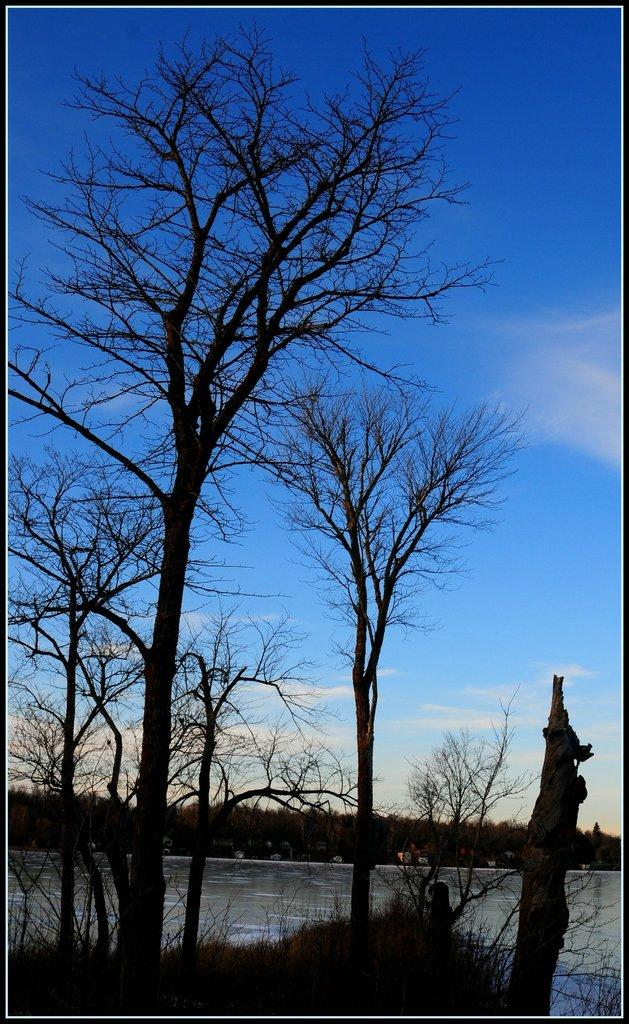What type of vegetation is present in the image? There is grass in the image. What is the condition of the trees in the image? The trees in the image are dry. What can be seen in the image besides vegetation? There is water visible in the image. What is the color of the sky in the background? The sky is blue in the background. What else can be seen in the sky? There are clouds in the sky. What direction is the feather blowing in the image? There is no feather present in the image. Is there a crown visible in the image? No, there is no crown visible in the image. 